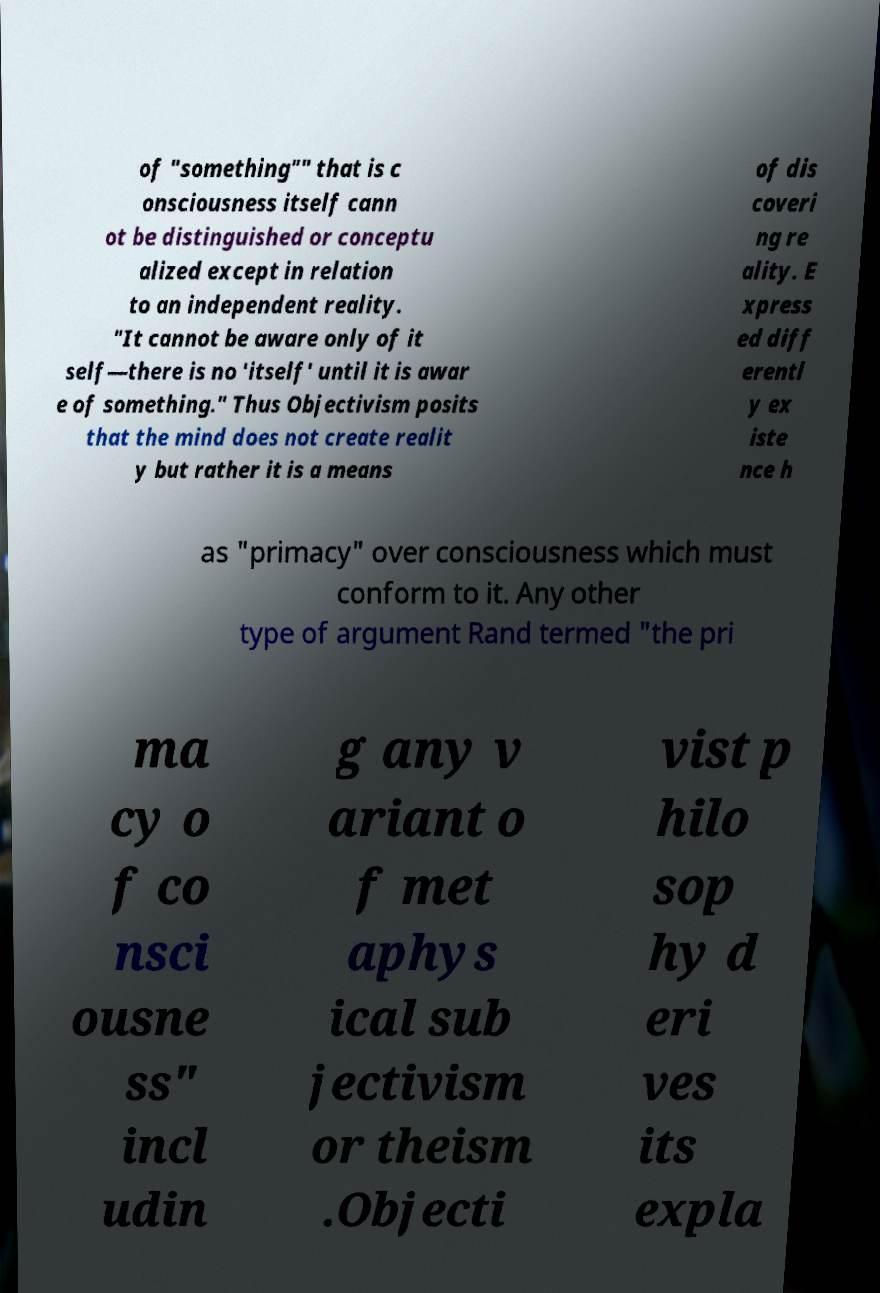I need the written content from this picture converted into text. Can you do that? of "something"" that is c onsciousness itself cann ot be distinguished or conceptu alized except in relation to an independent reality. "It cannot be aware only of it self—there is no 'itself' until it is awar e of something." Thus Objectivism posits that the mind does not create realit y but rather it is a means of dis coveri ng re ality. E xpress ed diff erentl y ex iste nce h as "primacy" over consciousness which must conform to it. Any other type of argument Rand termed "the pri ma cy o f co nsci ousne ss" incl udin g any v ariant o f met aphys ical sub jectivism or theism .Objecti vist p hilo sop hy d eri ves its expla 